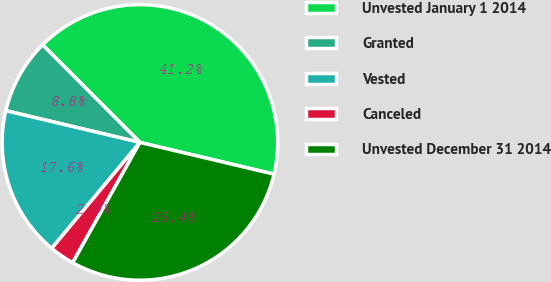Convert chart to OTSL. <chart><loc_0><loc_0><loc_500><loc_500><pie_chart><fcel>Unvested January 1 2014<fcel>Granted<fcel>Vested<fcel>Canceled<fcel>Unvested December 31 2014<nl><fcel>41.18%<fcel>8.82%<fcel>17.65%<fcel>2.94%<fcel>29.41%<nl></chart> 